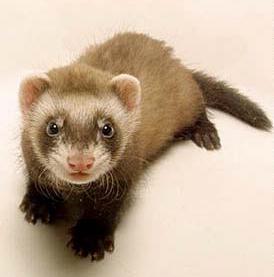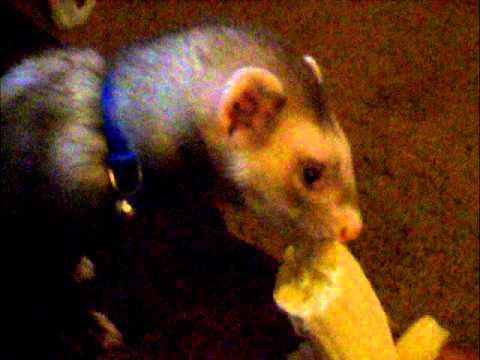The first image is the image on the left, the second image is the image on the right. Evaluate the accuracy of this statement regarding the images: "There are two ferrets eating something.". Is it true? Answer yes or no. No. The first image is the image on the left, the second image is the image on the right. Given the left and right images, does the statement "There is a partially peeled banana being eaten by a ferret in the left image." hold true? Answer yes or no. No. 